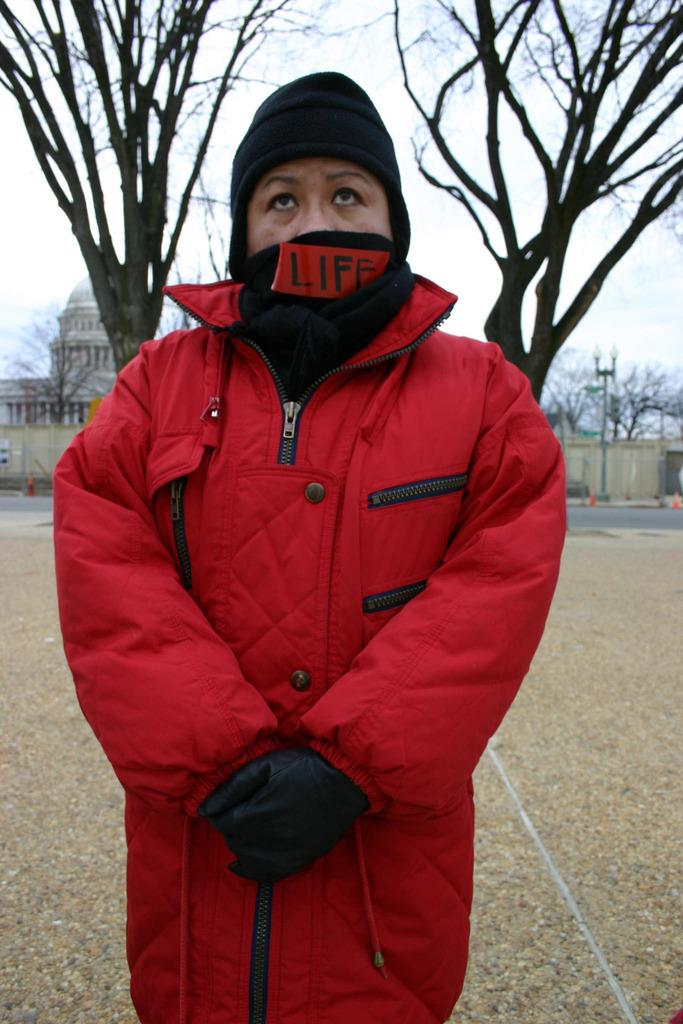What is the person in the image wearing? The person is wearing a jacket and a mask. What type of surface is the person standing on? The person is standing on land. What can be seen in the background of the image? There are trees, buildings, and the sky visible in the background of the image. What type of sheet is being used to cover the bell in the image? There is no bell or sheet present in the image. How many hens can be seen in the image? There are no hens present in the image. 